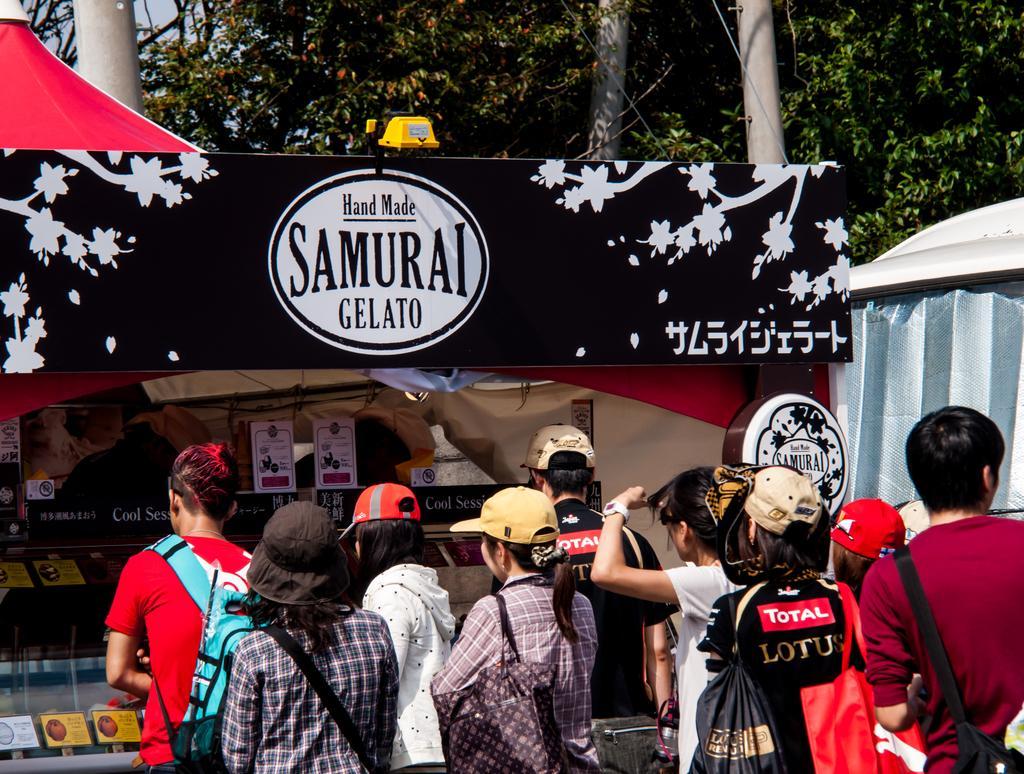How would you summarize this image in a sentence or two? In this image there are people standing and there is a stall. We can see a board. At the top there is a tent and we can see trees. 